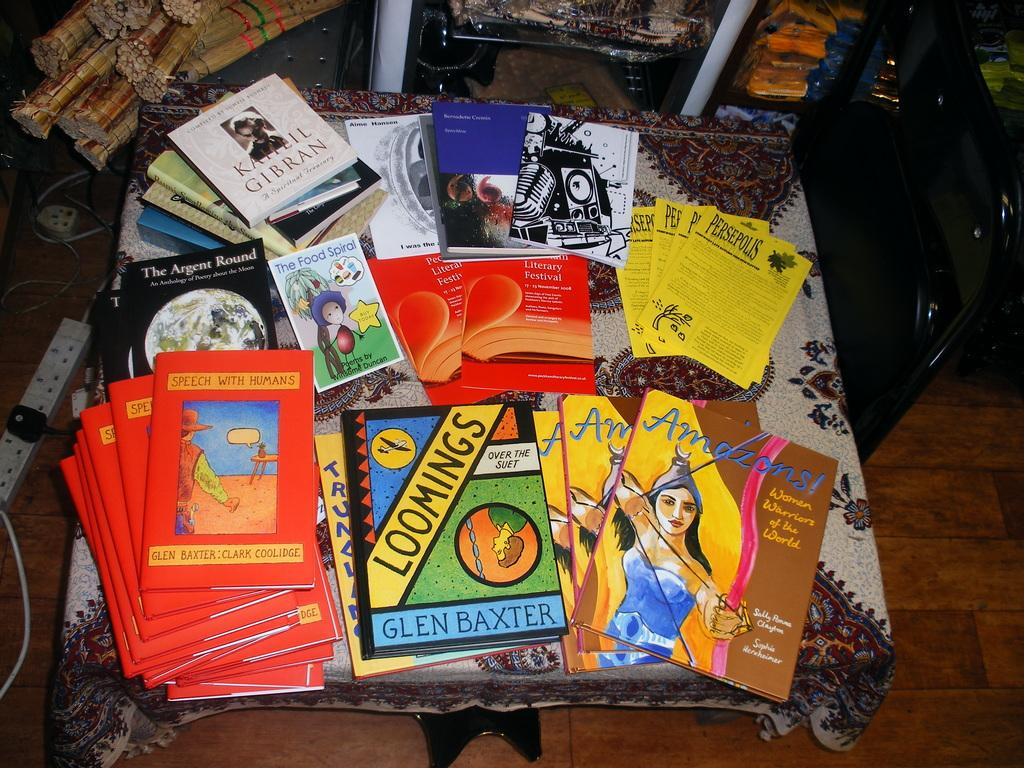<image>
Relay a brief, clear account of the picture shown. Various books are stacked on a table, including Loomings by Glen Baxter. 